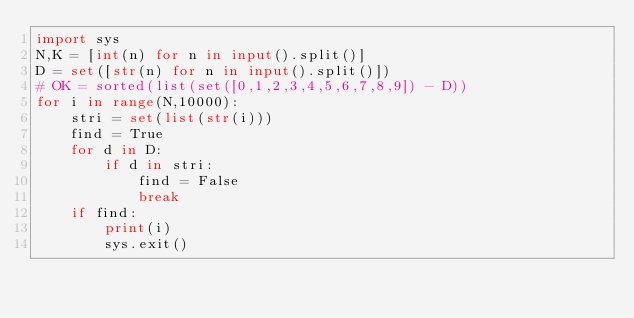Convert code to text. <code><loc_0><loc_0><loc_500><loc_500><_Python_>import sys
N,K = [int(n) for n in input().split()]
D = set([str(n) for n in input().split()])
# OK = sorted(list(set([0,1,2,3,4,5,6,7,8,9]) - D))
for i in range(N,10000):
    stri = set(list(str(i)))
    find = True
    for d in D:
        if d in stri:
            find = False
            break
    if find:
        print(i)
        sys.exit()</code> 